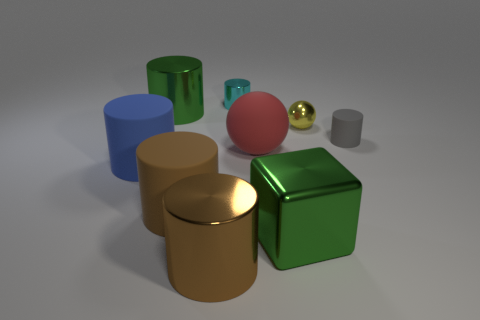Does the large brown cylinder behind the green metal block have the same material as the cylinder that is on the right side of the large shiny cube?
Give a very brief answer. Yes. Are there any other metal cylinders of the same size as the gray cylinder?
Provide a short and direct response. Yes. What is the shape of the green thing on the right side of the thing that is behind the large metal cylinder that is to the left of the large brown metal cylinder?
Provide a short and direct response. Cube. Are there more matte cylinders right of the brown rubber object than big blue rubber blocks?
Your response must be concise. Yes. Is there another big brown object of the same shape as the brown metallic object?
Keep it short and to the point. Yes. Are the big red ball and the sphere that is behind the gray thing made of the same material?
Your answer should be very brief. No. The cube is what color?
Your answer should be very brief. Green. There is a ball in front of the cylinder on the right side of the large green metallic cube; how many red spheres are behind it?
Give a very brief answer. 0. Are there any big blue matte cylinders in front of the big blue matte cylinder?
Your answer should be compact. No. What number of small gray cylinders are made of the same material as the big red object?
Make the answer very short. 1. 